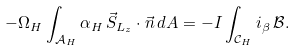<formula> <loc_0><loc_0><loc_500><loc_500>- \Omega _ { H } \int _ { \mathcal { A } _ { H } } \alpha _ { H } \, \vec { S } _ { L _ { z } } \cdot \vec { n } \, d A = - I \int _ { \mathcal { C } _ { H } } i _ { \beta } \, \mathcal { B } .</formula> 